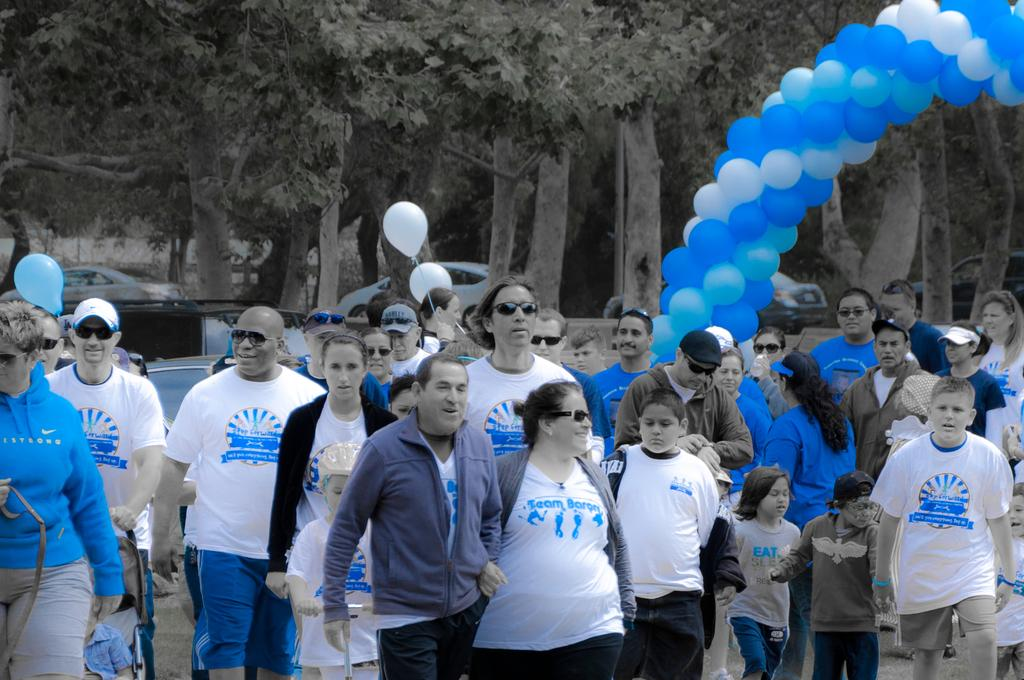What is happening on the road in the image? There is a crowd on the road in the image. What can be seen in the background of the image? There are balloons, vehicles, and trees in the background of the image. What time of day was the image taken? The image is taken during the day. Where is the sister sitting on the sofa in the image? There is no sister or sofa present in the image. 